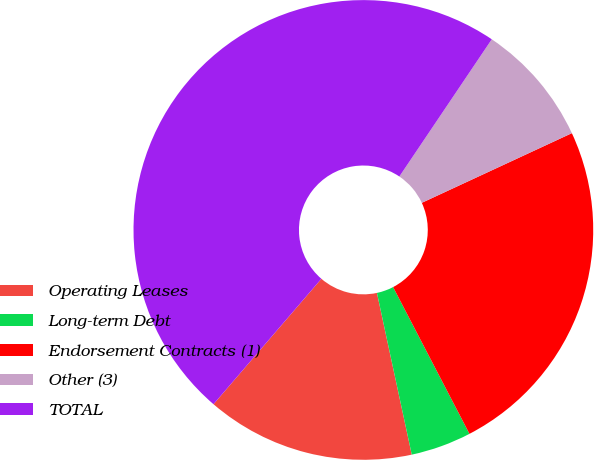Convert chart. <chart><loc_0><loc_0><loc_500><loc_500><pie_chart><fcel>Operating Leases<fcel>Long-term Debt<fcel>Endorsement Contracts (1)<fcel>Other (3)<fcel>TOTAL<nl><fcel>14.68%<fcel>4.26%<fcel>24.28%<fcel>8.65%<fcel>48.13%<nl></chart> 